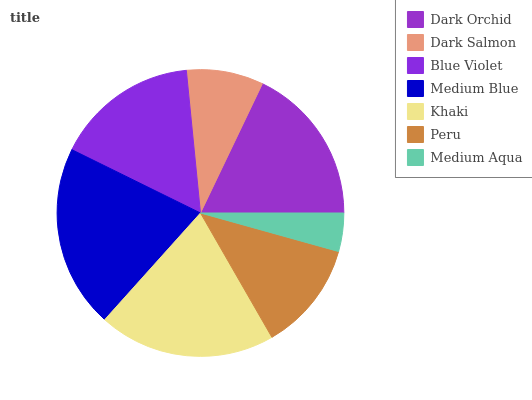Is Medium Aqua the minimum?
Answer yes or no. Yes. Is Medium Blue the maximum?
Answer yes or no. Yes. Is Dark Salmon the minimum?
Answer yes or no. No. Is Dark Salmon the maximum?
Answer yes or no. No. Is Dark Orchid greater than Dark Salmon?
Answer yes or no. Yes. Is Dark Salmon less than Dark Orchid?
Answer yes or no. Yes. Is Dark Salmon greater than Dark Orchid?
Answer yes or no. No. Is Dark Orchid less than Dark Salmon?
Answer yes or no. No. Is Blue Violet the high median?
Answer yes or no. Yes. Is Blue Violet the low median?
Answer yes or no. Yes. Is Dark Orchid the high median?
Answer yes or no. No. Is Khaki the low median?
Answer yes or no. No. 